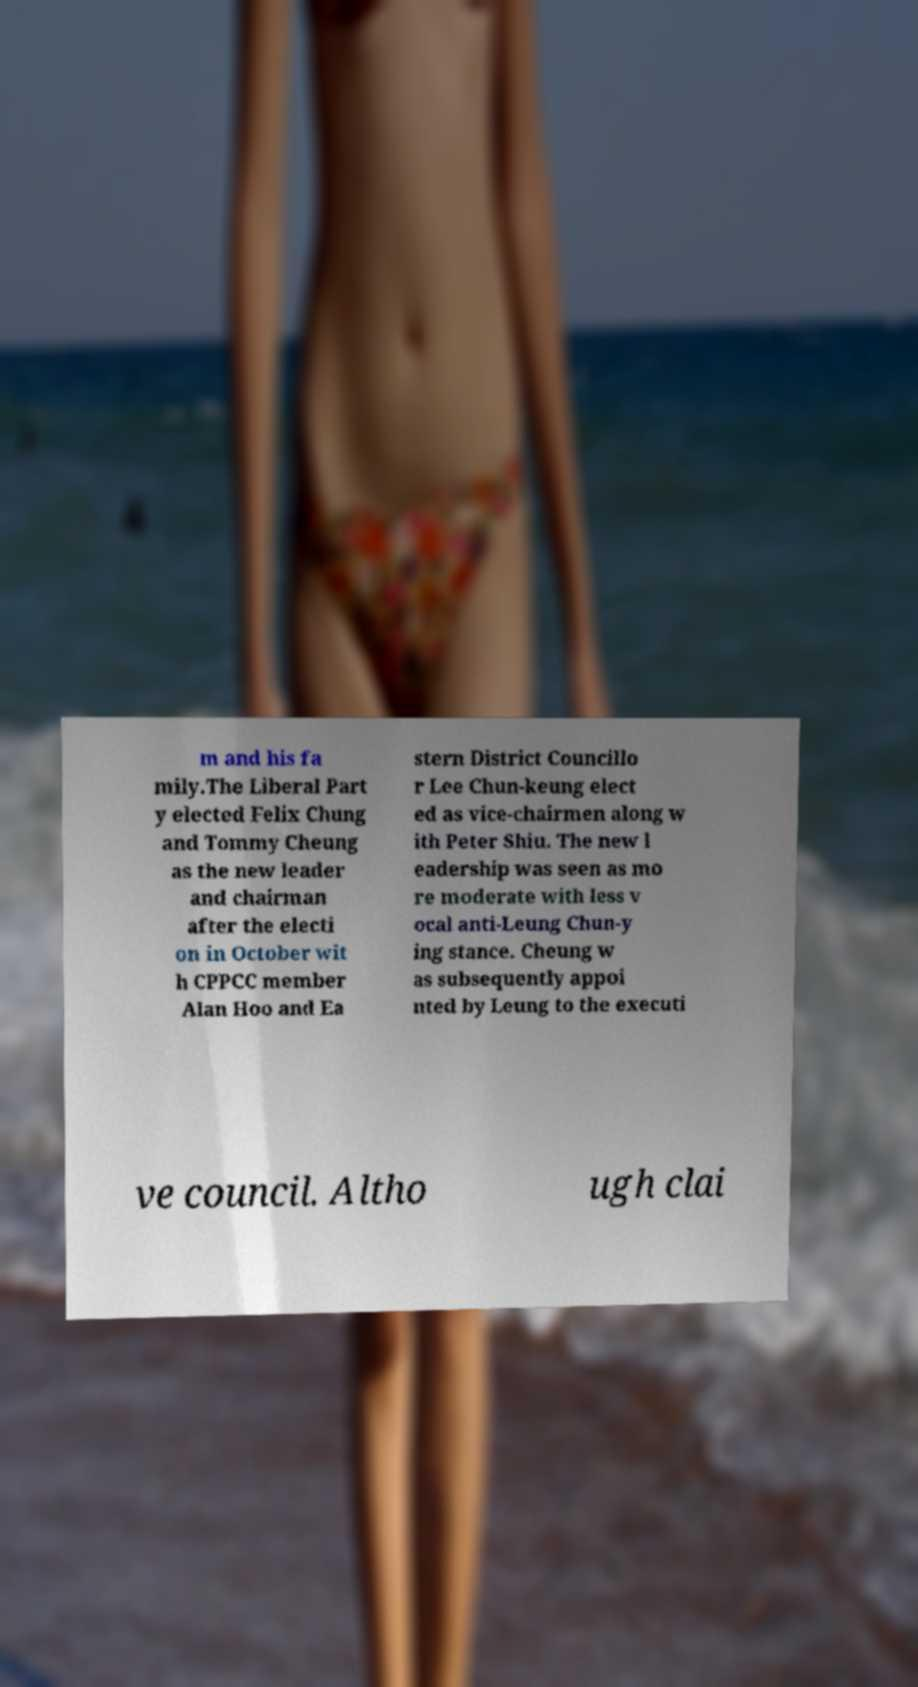Can you read and provide the text displayed in the image?This photo seems to have some interesting text. Can you extract and type it out for me? m and his fa mily.The Liberal Part y elected Felix Chung and Tommy Cheung as the new leader and chairman after the electi on in October wit h CPPCC member Alan Hoo and Ea stern District Councillo r Lee Chun-keung elect ed as vice-chairmen along w ith Peter Shiu. The new l eadership was seen as mo re moderate with less v ocal anti-Leung Chun-y ing stance. Cheung w as subsequently appoi nted by Leung to the executi ve council. Altho ugh clai 